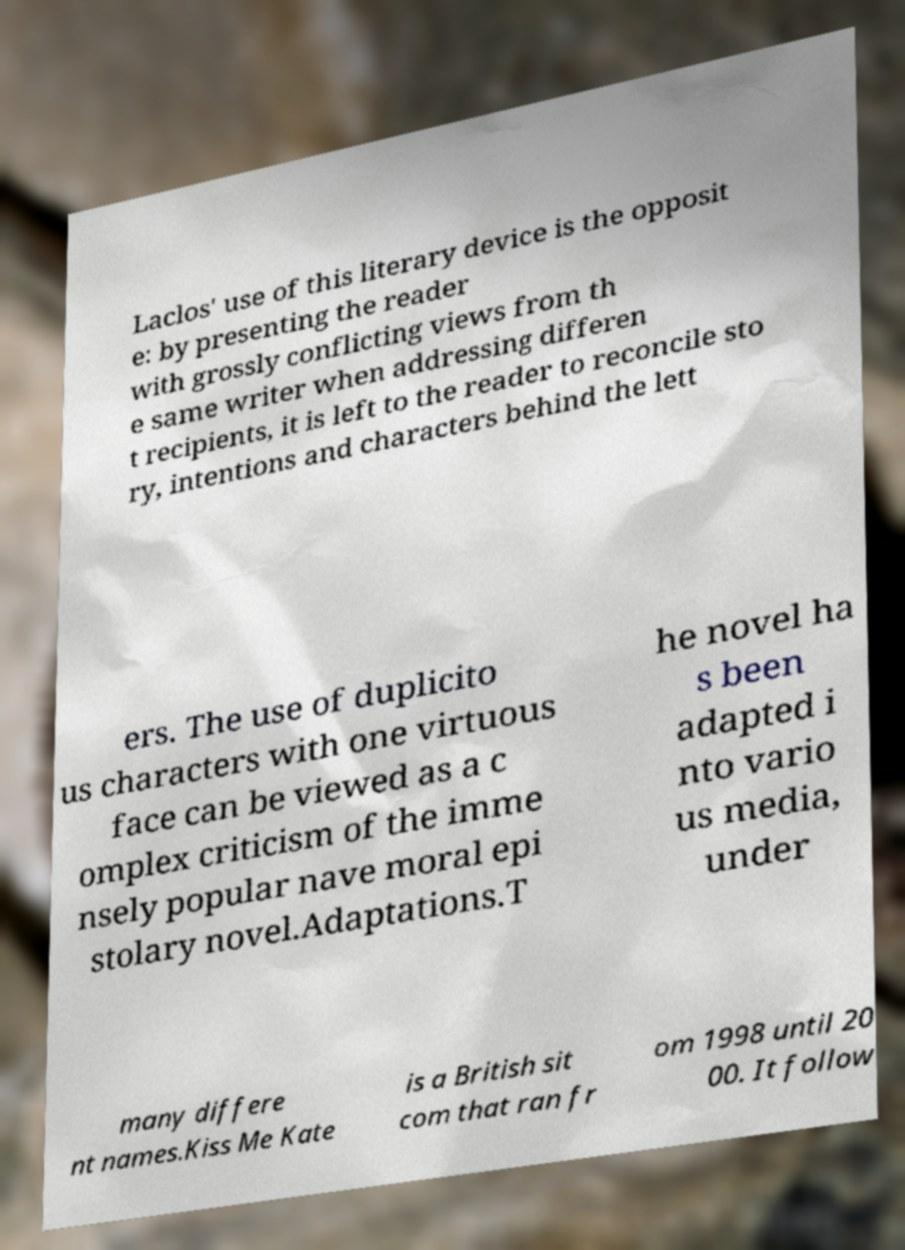Can you accurately transcribe the text from the provided image for me? Laclos' use of this literary device is the opposit e: by presenting the reader with grossly conflicting views from th e same writer when addressing differen t recipients, it is left to the reader to reconcile sto ry, intentions and characters behind the lett ers. The use of duplicito us characters with one virtuous face can be viewed as a c omplex criticism of the imme nsely popular nave moral epi stolary novel.Adaptations.T he novel ha s been adapted i nto vario us media, under many differe nt names.Kiss Me Kate is a British sit com that ran fr om 1998 until 20 00. It follow 